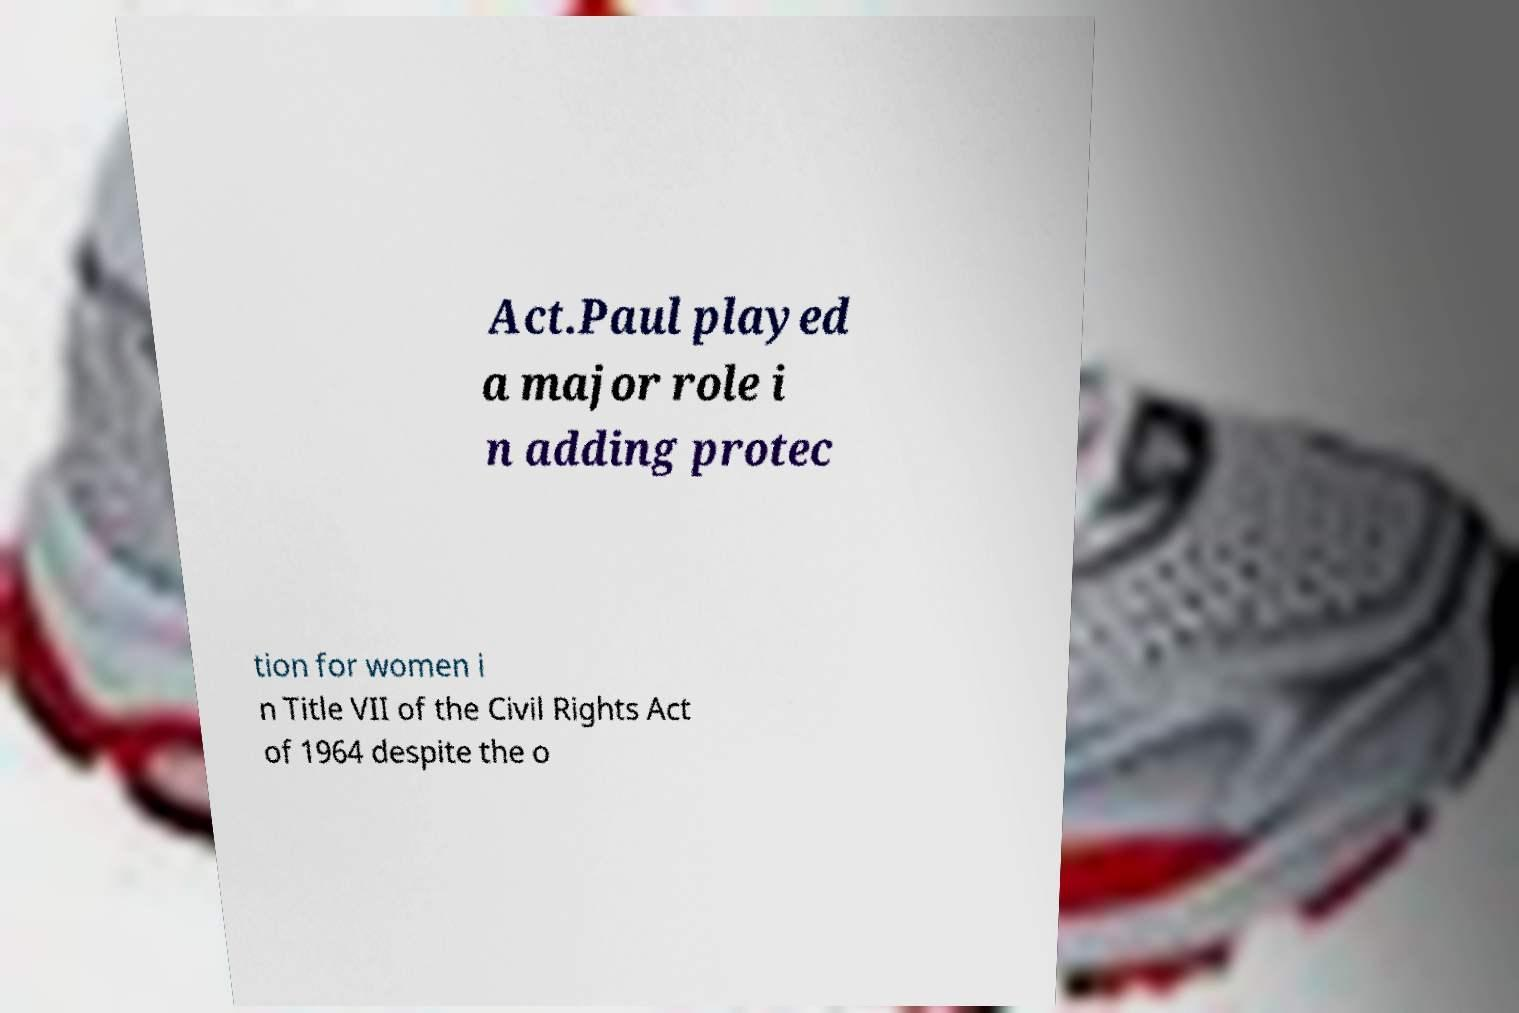For documentation purposes, I need the text within this image transcribed. Could you provide that? Act.Paul played a major role i n adding protec tion for women i n Title VII of the Civil Rights Act of 1964 despite the o 